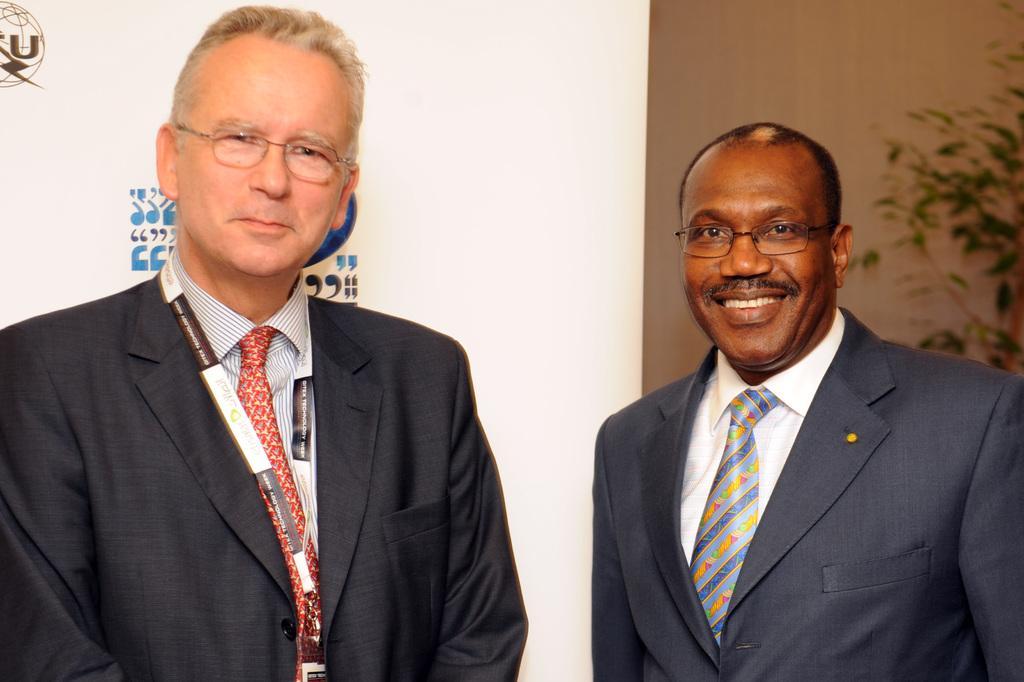How would you summarize this image in a sentence or two? This image consists of two persons. They are wearing blazers. There is a plant on the right side. 